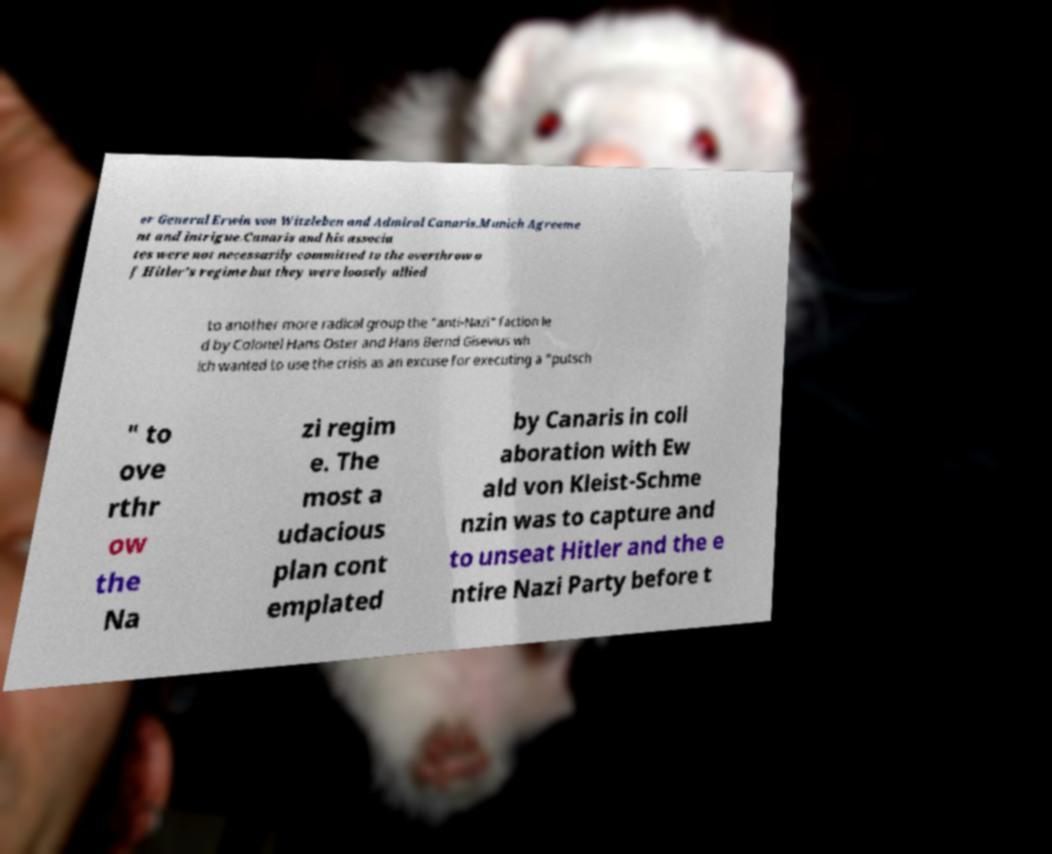What messages or text are displayed in this image? I need them in a readable, typed format. er General Erwin von Witzleben and Admiral Canaris.Munich Agreeme nt and intrigue.Canaris and his associa tes were not necessarily committed to the overthrow o f Hitler's regime but they were loosely allied to another more radical group the "anti-Nazi" faction le d by Colonel Hans Oster and Hans Bernd Gisevius wh ich wanted to use the crisis as an excuse for executing a "putsch " to ove rthr ow the Na zi regim e. The most a udacious plan cont emplated by Canaris in coll aboration with Ew ald von Kleist-Schme nzin was to capture and to unseat Hitler and the e ntire Nazi Party before t 